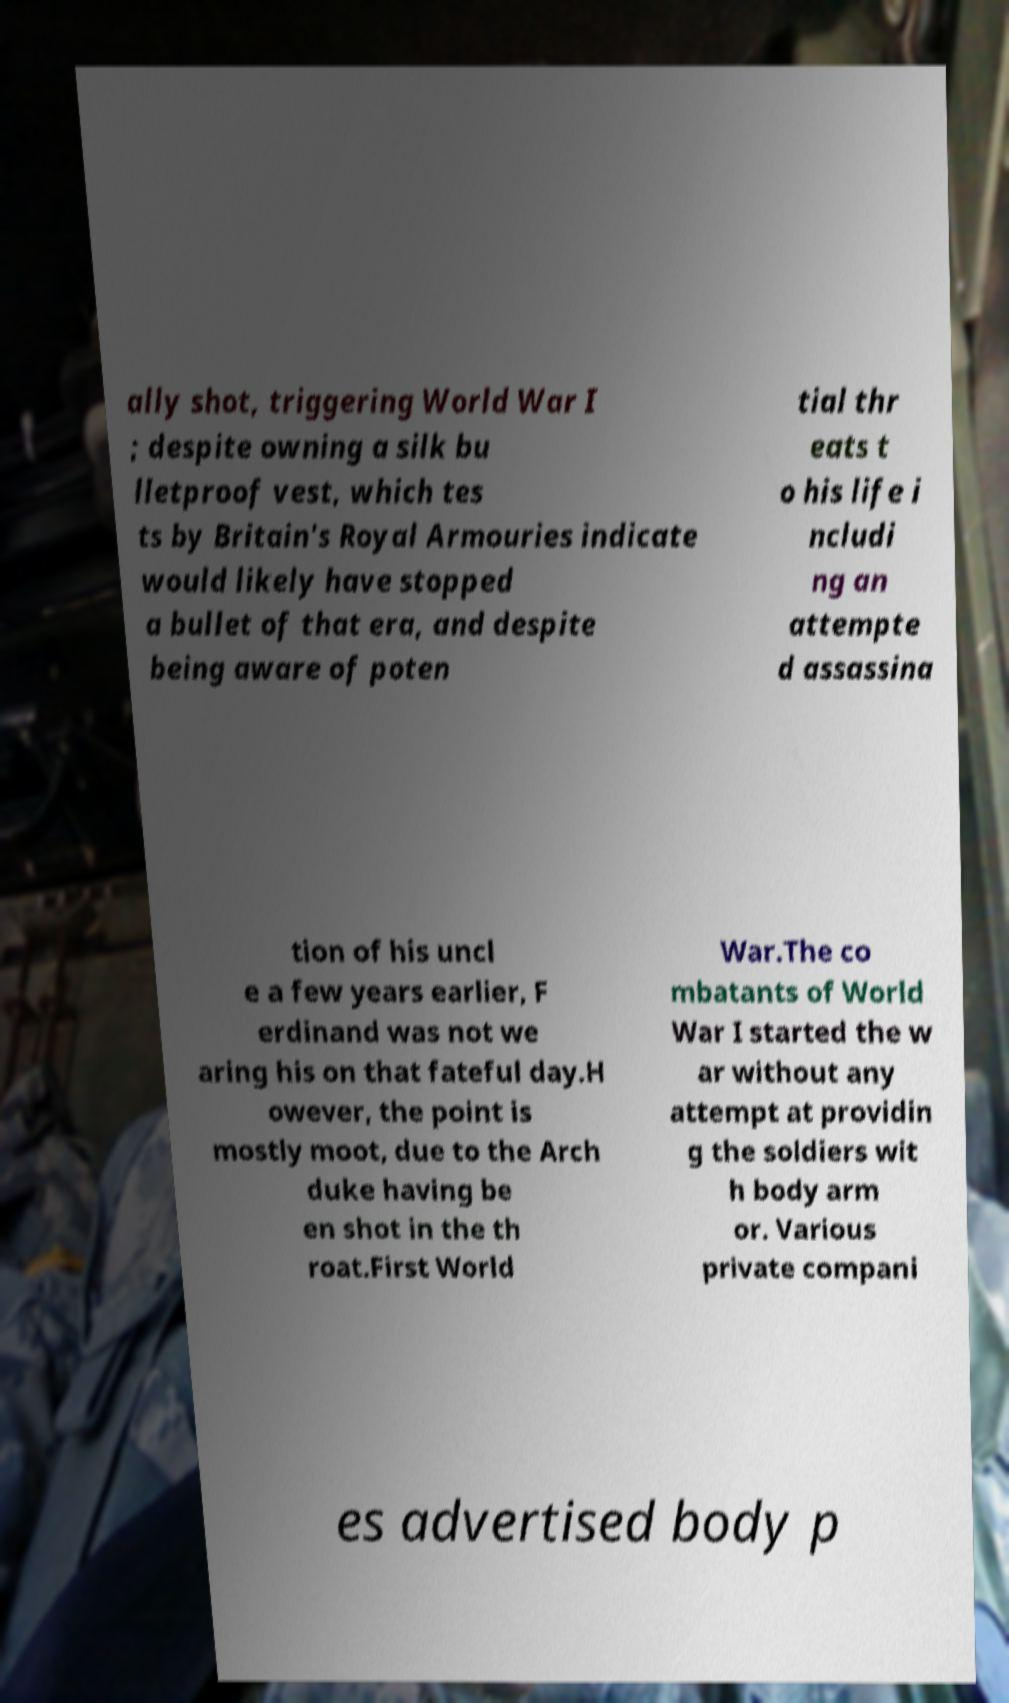Can you accurately transcribe the text from the provided image for me? ally shot, triggering World War I ; despite owning a silk bu lletproof vest, which tes ts by Britain's Royal Armouries indicate would likely have stopped a bullet of that era, and despite being aware of poten tial thr eats t o his life i ncludi ng an attempte d assassina tion of his uncl e a few years earlier, F erdinand was not we aring his on that fateful day.H owever, the point is mostly moot, due to the Arch duke having be en shot in the th roat.First World War.The co mbatants of World War I started the w ar without any attempt at providin g the soldiers wit h body arm or. Various private compani es advertised body p 